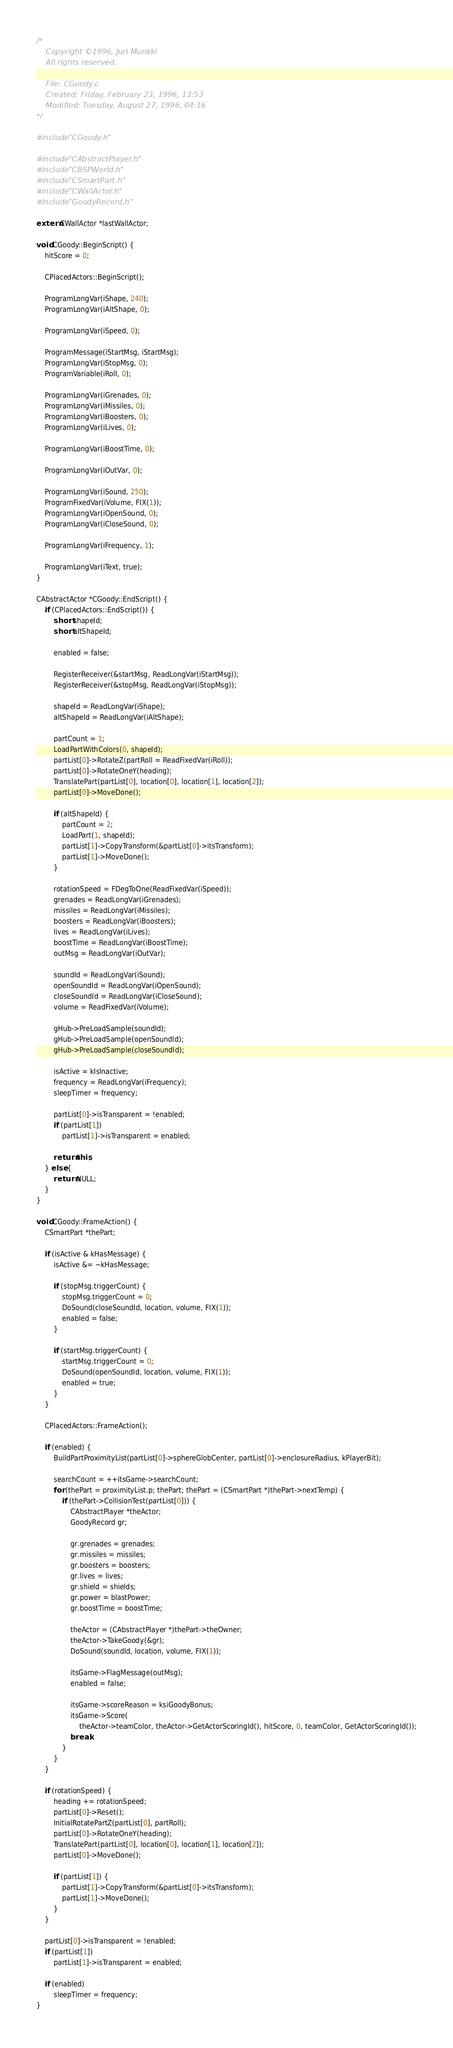Convert code to text. <code><loc_0><loc_0><loc_500><loc_500><_C++_>/*
    Copyright ©1996, Juri Munkki
    All rights reserved.

    File: CGoody.c
    Created: Friday, February 23, 1996, 13:53
    Modified: Tuesday, August 27, 1996, 04:16
*/

#include "CGoody.h"

#include "CAbstractPlayer.h"
#include "CBSPWorld.h"
#include "CSmartPart.h"
#include "CWallActor.h"
#include "GoodyRecord.h"

extern CWallActor *lastWallActor;

void CGoody::BeginScript() {
    hitScore = 0;

    CPlacedActors::BeginScript();

    ProgramLongVar(iShape, 240);
    ProgramLongVar(iAltShape, 0);

    ProgramLongVar(iSpeed, 0);

    ProgramMessage(iStartMsg, iStartMsg);
    ProgramLongVar(iStopMsg, 0);
    ProgramVariable(iRoll, 0);

    ProgramLongVar(iGrenades, 0);
    ProgramLongVar(iMissiles, 0);
    ProgramLongVar(iBoosters, 0);
    ProgramLongVar(iLives, 0);

    ProgramLongVar(iBoostTime, 0);

    ProgramLongVar(iOutVar, 0);

    ProgramLongVar(iSound, 250);
    ProgramFixedVar(iVolume, FIX(1));
    ProgramLongVar(iOpenSound, 0);
    ProgramLongVar(iCloseSound, 0);

    ProgramLongVar(iFrequency, 1);

    ProgramLongVar(iText, true);
}

CAbstractActor *CGoody::EndScript() {
    if (CPlacedActors::EndScript()) {
        short shapeId;
        short altShapeId;

        enabled = false;

        RegisterReceiver(&startMsg, ReadLongVar(iStartMsg));
        RegisterReceiver(&stopMsg, ReadLongVar(iStopMsg));

        shapeId = ReadLongVar(iShape);
        altShapeId = ReadLongVar(iAltShape);

        partCount = 1;
        LoadPartWithColors(0, shapeId);
        partList[0]->RotateZ(partRoll = ReadFixedVar(iRoll));
        partList[0]->RotateOneY(heading);
        TranslatePart(partList[0], location[0], location[1], location[2]);
        partList[0]->MoveDone();

        if (altShapeId) {
            partCount = 2;
            LoadPart(1, shapeId);
            partList[1]->CopyTransform(&partList[0]->itsTransform);
            partList[1]->MoveDone();
        }

        rotationSpeed = FDegToOne(ReadFixedVar(iSpeed));
        grenades = ReadLongVar(iGrenades);
        missiles = ReadLongVar(iMissiles);
        boosters = ReadLongVar(iBoosters);
        lives = ReadLongVar(iLives);
        boostTime = ReadLongVar(iBoostTime);
        outMsg = ReadLongVar(iOutVar);

        soundId = ReadLongVar(iSound);
        openSoundId = ReadLongVar(iOpenSound);
        closeSoundId = ReadLongVar(iCloseSound);
        volume = ReadFixedVar(iVolume);

        gHub->PreLoadSample(soundId);
        gHub->PreLoadSample(openSoundId);
        gHub->PreLoadSample(closeSoundId);

        isActive = kIsInactive;
        frequency = ReadLongVar(iFrequency);
        sleepTimer = frequency;

        partList[0]->isTransparent = !enabled;
        if (partList[1])
            partList[1]->isTransparent = enabled;

        return this;
    } else {
        return NULL;
    }
}

void CGoody::FrameAction() {
    CSmartPart *thePart;

    if (isActive & kHasMessage) {
        isActive &= ~kHasMessage;

        if (stopMsg.triggerCount) {
            stopMsg.triggerCount = 0;
            DoSound(closeSoundId, location, volume, FIX(1));
            enabled = false;
        }

        if (startMsg.triggerCount) {
            startMsg.triggerCount = 0;
            DoSound(openSoundId, location, volume, FIX(1));
            enabled = true;
        }
    }

    CPlacedActors::FrameAction();

    if (enabled) {
        BuildPartProximityList(partList[0]->sphereGlobCenter, partList[0]->enclosureRadius, kPlayerBit);

        searchCount = ++itsGame->searchCount;
        for (thePart = proximityList.p; thePart; thePart = (CSmartPart *)thePart->nextTemp) {
            if (thePart->CollisionTest(partList[0])) {
                CAbstractPlayer *theActor;
                GoodyRecord gr;

                gr.grenades = grenades;
                gr.missiles = missiles;
                gr.boosters = boosters;
                gr.lives = lives;
                gr.shield = shields;
                gr.power = blastPower;
                gr.boostTime = boostTime;

                theActor = (CAbstractPlayer *)thePart->theOwner;
                theActor->TakeGoody(&gr);
                DoSound(soundId, location, volume, FIX(1));

                itsGame->FlagMessage(outMsg);
                enabled = false;

                itsGame->scoreReason = ksiGoodyBonus;
                itsGame->Score(
                    theActor->teamColor, theActor->GetActorScoringId(), hitScore, 0, teamColor, GetActorScoringId());
                break;
            }
        }
    }

    if (rotationSpeed) {
        heading += rotationSpeed;
        partList[0]->Reset();
        InitialRotatePartZ(partList[0], partRoll);
        partList[0]->RotateOneY(heading);
        TranslatePart(partList[0], location[0], location[1], location[2]);
        partList[0]->MoveDone();

        if (partList[1]) {
            partList[1]->CopyTransform(&partList[0]->itsTransform);
            partList[1]->MoveDone();
        }
    }

    partList[0]->isTransparent = !enabled;
    if (partList[1])
        partList[1]->isTransparent = enabled;

    if (enabled)
        sleepTimer = frequency;
}
</code> 